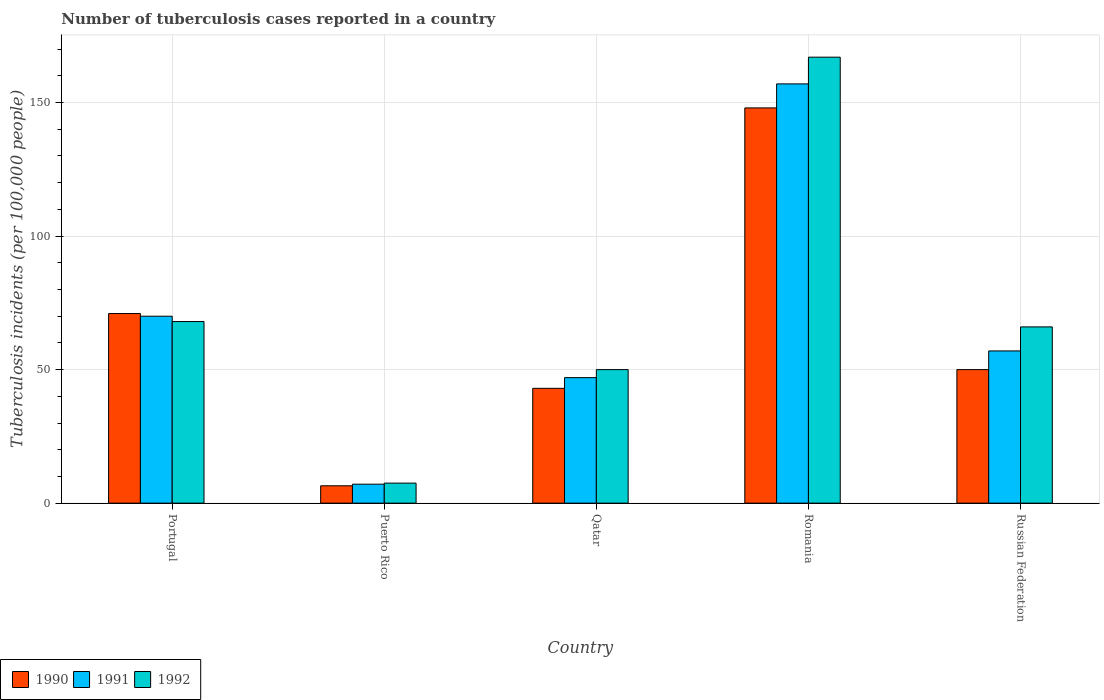How many groups of bars are there?
Your answer should be very brief. 5. Are the number of bars per tick equal to the number of legend labels?
Provide a short and direct response. Yes. How many bars are there on the 3rd tick from the right?
Keep it short and to the point. 3. What is the label of the 3rd group of bars from the left?
Provide a succinct answer. Qatar. What is the number of tuberculosis cases reported in in 1990 in Russian Federation?
Give a very brief answer. 50. Across all countries, what is the maximum number of tuberculosis cases reported in in 1992?
Your response must be concise. 167. Across all countries, what is the minimum number of tuberculosis cases reported in in 1991?
Make the answer very short. 7.1. In which country was the number of tuberculosis cases reported in in 1992 maximum?
Keep it short and to the point. Romania. In which country was the number of tuberculosis cases reported in in 1992 minimum?
Your answer should be compact. Puerto Rico. What is the total number of tuberculosis cases reported in in 1991 in the graph?
Give a very brief answer. 338.1. What is the difference between the number of tuberculosis cases reported in in 1992 in Portugal and that in Puerto Rico?
Your response must be concise. 60.5. What is the average number of tuberculosis cases reported in in 1991 per country?
Provide a short and direct response. 67.62. In how many countries, is the number of tuberculosis cases reported in in 1991 greater than 50?
Your response must be concise. 3. What is the ratio of the number of tuberculosis cases reported in in 1991 in Portugal to that in Puerto Rico?
Provide a short and direct response. 9.86. What is the difference between the highest and the second highest number of tuberculosis cases reported in in 1990?
Provide a short and direct response. -98. What is the difference between the highest and the lowest number of tuberculosis cases reported in in 1992?
Your response must be concise. 159.5. What does the 3rd bar from the left in Puerto Rico represents?
Keep it short and to the point. 1992. How many bars are there?
Provide a succinct answer. 15. Are all the bars in the graph horizontal?
Your response must be concise. No. Are the values on the major ticks of Y-axis written in scientific E-notation?
Offer a terse response. No. Does the graph contain grids?
Your answer should be very brief. Yes. How many legend labels are there?
Your answer should be very brief. 3. What is the title of the graph?
Provide a succinct answer. Number of tuberculosis cases reported in a country. What is the label or title of the Y-axis?
Your answer should be very brief. Tuberculosis incidents (per 100,0 people). What is the Tuberculosis incidents (per 100,000 people) of 1992 in Portugal?
Keep it short and to the point. 68. What is the Tuberculosis incidents (per 100,000 people) of 1990 in Puerto Rico?
Your response must be concise. 6.5. What is the Tuberculosis incidents (per 100,000 people) of 1992 in Puerto Rico?
Keep it short and to the point. 7.5. What is the Tuberculosis incidents (per 100,000 people) of 1990 in Qatar?
Offer a very short reply. 43. What is the Tuberculosis incidents (per 100,000 people) of 1990 in Romania?
Offer a very short reply. 148. What is the Tuberculosis incidents (per 100,000 people) of 1991 in Romania?
Ensure brevity in your answer.  157. What is the Tuberculosis incidents (per 100,000 people) of 1992 in Romania?
Your answer should be very brief. 167. Across all countries, what is the maximum Tuberculosis incidents (per 100,000 people) in 1990?
Offer a very short reply. 148. Across all countries, what is the maximum Tuberculosis incidents (per 100,000 people) in 1991?
Give a very brief answer. 157. Across all countries, what is the maximum Tuberculosis incidents (per 100,000 people) in 1992?
Make the answer very short. 167. Across all countries, what is the minimum Tuberculosis incidents (per 100,000 people) of 1990?
Provide a short and direct response. 6.5. Across all countries, what is the minimum Tuberculosis incidents (per 100,000 people) in 1992?
Your answer should be compact. 7.5. What is the total Tuberculosis incidents (per 100,000 people) of 1990 in the graph?
Your answer should be compact. 318.5. What is the total Tuberculosis incidents (per 100,000 people) of 1991 in the graph?
Offer a very short reply. 338.1. What is the total Tuberculosis incidents (per 100,000 people) in 1992 in the graph?
Make the answer very short. 358.5. What is the difference between the Tuberculosis incidents (per 100,000 people) in 1990 in Portugal and that in Puerto Rico?
Your answer should be very brief. 64.5. What is the difference between the Tuberculosis incidents (per 100,000 people) of 1991 in Portugal and that in Puerto Rico?
Your response must be concise. 62.9. What is the difference between the Tuberculosis incidents (per 100,000 people) of 1992 in Portugal and that in Puerto Rico?
Your response must be concise. 60.5. What is the difference between the Tuberculosis incidents (per 100,000 people) in 1990 in Portugal and that in Qatar?
Offer a terse response. 28. What is the difference between the Tuberculosis incidents (per 100,000 people) of 1991 in Portugal and that in Qatar?
Your response must be concise. 23. What is the difference between the Tuberculosis incidents (per 100,000 people) in 1992 in Portugal and that in Qatar?
Offer a very short reply. 18. What is the difference between the Tuberculosis incidents (per 100,000 people) of 1990 in Portugal and that in Romania?
Provide a succinct answer. -77. What is the difference between the Tuberculosis incidents (per 100,000 people) of 1991 in Portugal and that in Romania?
Ensure brevity in your answer.  -87. What is the difference between the Tuberculosis incidents (per 100,000 people) in 1992 in Portugal and that in Romania?
Give a very brief answer. -99. What is the difference between the Tuberculosis incidents (per 100,000 people) of 1991 in Portugal and that in Russian Federation?
Keep it short and to the point. 13. What is the difference between the Tuberculosis incidents (per 100,000 people) of 1992 in Portugal and that in Russian Federation?
Keep it short and to the point. 2. What is the difference between the Tuberculosis incidents (per 100,000 people) of 1990 in Puerto Rico and that in Qatar?
Keep it short and to the point. -36.5. What is the difference between the Tuberculosis incidents (per 100,000 people) of 1991 in Puerto Rico and that in Qatar?
Keep it short and to the point. -39.9. What is the difference between the Tuberculosis incidents (per 100,000 people) of 1992 in Puerto Rico and that in Qatar?
Your answer should be compact. -42.5. What is the difference between the Tuberculosis incidents (per 100,000 people) in 1990 in Puerto Rico and that in Romania?
Provide a short and direct response. -141.5. What is the difference between the Tuberculosis incidents (per 100,000 people) in 1991 in Puerto Rico and that in Romania?
Ensure brevity in your answer.  -149.9. What is the difference between the Tuberculosis incidents (per 100,000 people) of 1992 in Puerto Rico and that in Romania?
Your answer should be compact. -159.5. What is the difference between the Tuberculosis incidents (per 100,000 people) of 1990 in Puerto Rico and that in Russian Federation?
Your answer should be very brief. -43.5. What is the difference between the Tuberculosis incidents (per 100,000 people) in 1991 in Puerto Rico and that in Russian Federation?
Offer a terse response. -49.9. What is the difference between the Tuberculosis incidents (per 100,000 people) of 1992 in Puerto Rico and that in Russian Federation?
Offer a terse response. -58.5. What is the difference between the Tuberculosis incidents (per 100,000 people) in 1990 in Qatar and that in Romania?
Keep it short and to the point. -105. What is the difference between the Tuberculosis incidents (per 100,000 people) of 1991 in Qatar and that in Romania?
Ensure brevity in your answer.  -110. What is the difference between the Tuberculosis incidents (per 100,000 people) of 1992 in Qatar and that in Romania?
Offer a terse response. -117. What is the difference between the Tuberculosis incidents (per 100,000 people) of 1990 in Qatar and that in Russian Federation?
Your answer should be very brief. -7. What is the difference between the Tuberculosis incidents (per 100,000 people) of 1991 in Qatar and that in Russian Federation?
Provide a succinct answer. -10. What is the difference between the Tuberculosis incidents (per 100,000 people) in 1992 in Qatar and that in Russian Federation?
Ensure brevity in your answer.  -16. What is the difference between the Tuberculosis incidents (per 100,000 people) in 1991 in Romania and that in Russian Federation?
Your answer should be very brief. 100. What is the difference between the Tuberculosis incidents (per 100,000 people) in 1992 in Romania and that in Russian Federation?
Make the answer very short. 101. What is the difference between the Tuberculosis incidents (per 100,000 people) in 1990 in Portugal and the Tuberculosis incidents (per 100,000 people) in 1991 in Puerto Rico?
Ensure brevity in your answer.  63.9. What is the difference between the Tuberculosis incidents (per 100,000 people) in 1990 in Portugal and the Tuberculosis incidents (per 100,000 people) in 1992 in Puerto Rico?
Keep it short and to the point. 63.5. What is the difference between the Tuberculosis incidents (per 100,000 people) of 1991 in Portugal and the Tuberculosis incidents (per 100,000 people) of 1992 in Puerto Rico?
Your answer should be compact. 62.5. What is the difference between the Tuberculosis incidents (per 100,000 people) in 1990 in Portugal and the Tuberculosis incidents (per 100,000 people) in 1991 in Qatar?
Keep it short and to the point. 24. What is the difference between the Tuberculosis incidents (per 100,000 people) of 1990 in Portugal and the Tuberculosis incidents (per 100,000 people) of 1992 in Qatar?
Offer a terse response. 21. What is the difference between the Tuberculosis incidents (per 100,000 people) of 1991 in Portugal and the Tuberculosis incidents (per 100,000 people) of 1992 in Qatar?
Offer a very short reply. 20. What is the difference between the Tuberculosis incidents (per 100,000 people) of 1990 in Portugal and the Tuberculosis incidents (per 100,000 people) of 1991 in Romania?
Offer a terse response. -86. What is the difference between the Tuberculosis incidents (per 100,000 people) in 1990 in Portugal and the Tuberculosis incidents (per 100,000 people) in 1992 in Romania?
Provide a short and direct response. -96. What is the difference between the Tuberculosis incidents (per 100,000 people) of 1991 in Portugal and the Tuberculosis incidents (per 100,000 people) of 1992 in Romania?
Offer a very short reply. -97. What is the difference between the Tuberculosis incidents (per 100,000 people) of 1990 in Portugal and the Tuberculosis incidents (per 100,000 people) of 1991 in Russian Federation?
Ensure brevity in your answer.  14. What is the difference between the Tuberculosis incidents (per 100,000 people) of 1990 in Portugal and the Tuberculosis incidents (per 100,000 people) of 1992 in Russian Federation?
Your response must be concise. 5. What is the difference between the Tuberculosis incidents (per 100,000 people) in 1990 in Puerto Rico and the Tuberculosis incidents (per 100,000 people) in 1991 in Qatar?
Offer a terse response. -40.5. What is the difference between the Tuberculosis incidents (per 100,000 people) of 1990 in Puerto Rico and the Tuberculosis incidents (per 100,000 people) of 1992 in Qatar?
Give a very brief answer. -43.5. What is the difference between the Tuberculosis incidents (per 100,000 people) of 1991 in Puerto Rico and the Tuberculosis incidents (per 100,000 people) of 1992 in Qatar?
Your answer should be compact. -42.9. What is the difference between the Tuberculosis incidents (per 100,000 people) in 1990 in Puerto Rico and the Tuberculosis incidents (per 100,000 people) in 1991 in Romania?
Provide a succinct answer. -150.5. What is the difference between the Tuberculosis incidents (per 100,000 people) of 1990 in Puerto Rico and the Tuberculosis incidents (per 100,000 people) of 1992 in Romania?
Your answer should be compact. -160.5. What is the difference between the Tuberculosis incidents (per 100,000 people) of 1991 in Puerto Rico and the Tuberculosis incidents (per 100,000 people) of 1992 in Romania?
Offer a very short reply. -159.9. What is the difference between the Tuberculosis incidents (per 100,000 people) in 1990 in Puerto Rico and the Tuberculosis incidents (per 100,000 people) in 1991 in Russian Federation?
Ensure brevity in your answer.  -50.5. What is the difference between the Tuberculosis incidents (per 100,000 people) in 1990 in Puerto Rico and the Tuberculosis incidents (per 100,000 people) in 1992 in Russian Federation?
Keep it short and to the point. -59.5. What is the difference between the Tuberculosis incidents (per 100,000 people) in 1991 in Puerto Rico and the Tuberculosis incidents (per 100,000 people) in 1992 in Russian Federation?
Ensure brevity in your answer.  -58.9. What is the difference between the Tuberculosis incidents (per 100,000 people) in 1990 in Qatar and the Tuberculosis incidents (per 100,000 people) in 1991 in Romania?
Offer a very short reply. -114. What is the difference between the Tuberculosis incidents (per 100,000 people) of 1990 in Qatar and the Tuberculosis incidents (per 100,000 people) of 1992 in Romania?
Offer a terse response. -124. What is the difference between the Tuberculosis incidents (per 100,000 people) of 1991 in Qatar and the Tuberculosis incidents (per 100,000 people) of 1992 in Romania?
Your answer should be compact. -120. What is the difference between the Tuberculosis incidents (per 100,000 people) in 1990 in Romania and the Tuberculosis incidents (per 100,000 people) in 1991 in Russian Federation?
Ensure brevity in your answer.  91. What is the difference between the Tuberculosis incidents (per 100,000 people) in 1991 in Romania and the Tuberculosis incidents (per 100,000 people) in 1992 in Russian Federation?
Ensure brevity in your answer.  91. What is the average Tuberculosis incidents (per 100,000 people) of 1990 per country?
Provide a short and direct response. 63.7. What is the average Tuberculosis incidents (per 100,000 people) in 1991 per country?
Offer a terse response. 67.62. What is the average Tuberculosis incidents (per 100,000 people) of 1992 per country?
Offer a terse response. 71.7. What is the difference between the Tuberculosis incidents (per 100,000 people) of 1990 and Tuberculosis incidents (per 100,000 people) of 1991 in Portugal?
Give a very brief answer. 1. What is the difference between the Tuberculosis incidents (per 100,000 people) in 1991 and Tuberculosis incidents (per 100,000 people) in 1992 in Portugal?
Provide a succinct answer. 2. What is the difference between the Tuberculosis incidents (per 100,000 people) in 1990 and Tuberculosis incidents (per 100,000 people) in 1991 in Puerto Rico?
Offer a terse response. -0.6. What is the difference between the Tuberculosis incidents (per 100,000 people) of 1991 and Tuberculosis incidents (per 100,000 people) of 1992 in Puerto Rico?
Your answer should be very brief. -0.4. What is the difference between the Tuberculosis incidents (per 100,000 people) in 1990 and Tuberculosis incidents (per 100,000 people) in 1991 in Qatar?
Your response must be concise. -4. What is the difference between the Tuberculosis incidents (per 100,000 people) of 1991 and Tuberculosis incidents (per 100,000 people) of 1992 in Qatar?
Offer a very short reply. -3. What is the difference between the Tuberculosis incidents (per 100,000 people) in 1991 and Tuberculosis incidents (per 100,000 people) in 1992 in Romania?
Your response must be concise. -10. What is the difference between the Tuberculosis incidents (per 100,000 people) in 1990 and Tuberculosis incidents (per 100,000 people) in 1992 in Russian Federation?
Provide a short and direct response. -16. What is the difference between the Tuberculosis incidents (per 100,000 people) of 1991 and Tuberculosis incidents (per 100,000 people) of 1992 in Russian Federation?
Keep it short and to the point. -9. What is the ratio of the Tuberculosis incidents (per 100,000 people) of 1990 in Portugal to that in Puerto Rico?
Make the answer very short. 10.92. What is the ratio of the Tuberculosis incidents (per 100,000 people) in 1991 in Portugal to that in Puerto Rico?
Provide a short and direct response. 9.86. What is the ratio of the Tuberculosis incidents (per 100,000 people) in 1992 in Portugal to that in Puerto Rico?
Your answer should be very brief. 9.07. What is the ratio of the Tuberculosis incidents (per 100,000 people) in 1990 in Portugal to that in Qatar?
Keep it short and to the point. 1.65. What is the ratio of the Tuberculosis incidents (per 100,000 people) of 1991 in Portugal to that in Qatar?
Make the answer very short. 1.49. What is the ratio of the Tuberculosis incidents (per 100,000 people) of 1992 in Portugal to that in Qatar?
Offer a very short reply. 1.36. What is the ratio of the Tuberculosis incidents (per 100,000 people) of 1990 in Portugal to that in Romania?
Offer a very short reply. 0.48. What is the ratio of the Tuberculosis incidents (per 100,000 people) of 1991 in Portugal to that in Romania?
Give a very brief answer. 0.45. What is the ratio of the Tuberculosis incidents (per 100,000 people) of 1992 in Portugal to that in Romania?
Your response must be concise. 0.41. What is the ratio of the Tuberculosis incidents (per 100,000 people) of 1990 in Portugal to that in Russian Federation?
Provide a succinct answer. 1.42. What is the ratio of the Tuberculosis incidents (per 100,000 people) of 1991 in Portugal to that in Russian Federation?
Your answer should be very brief. 1.23. What is the ratio of the Tuberculosis incidents (per 100,000 people) of 1992 in Portugal to that in Russian Federation?
Provide a short and direct response. 1.03. What is the ratio of the Tuberculosis incidents (per 100,000 people) in 1990 in Puerto Rico to that in Qatar?
Give a very brief answer. 0.15. What is the ratio of the Tuberculosis incidents (per 100,000 people) of 1991 in Puerto Rico to that in Qatar?
Ensure brevity in your answer.  0.15. What is the ratio of the Tuberculosis incidents (per 100,000 people) in 1992 in Puerto Rico to that in Qatar?
Offer a terse response. 0.15. What is the ratio of the Tuberculosis incidents (per 100,000 people) in 1990 in Puerto Rico to that in Romania?
Your answer should be very brief. 0.04. What is the ratio of the Tuberculosis incidents (per 100,000 people) of 1991 in Puerto Rico to that in Romania?
Offer a very short reply. 0.05. What is the ratio of the Tuberculosis incidents (per 100,000 people) in 1992 in Puerto Rico to that in Romania?
Your answer should be compact. 0.04. What is the ratio of the Tuberculosis incidents (per 100,000 people) of 1990 in Puerto Rico to that in Russian Federation?
Your response must be concise. 0.13. What is the ratio of the Tuberculosis incidents (per 100,000 people) of 1991 in Puerto Rico to that in Russian Federation?
Your answer should be very brief. 0.12. What is the ratio of the Tuberculosis incidents (per 100,000 people) of 1992 in Puerto Rico to that in Russian Federation?
Your answer should be compact. 0.11. What is the ratio of the Tuberculosis incidents (per 100,000 people) of 1990 in Qatar to that in Romania?
Your response must be concise. 0.29. What is the ratio of the Tuberculosis incidents (per 100,000 people) of 1991 in Qatar to that in Romania?
Your answer should be compact. 0.3. What is the ratio of the Tuberculosis incidents (per 100,000 people) of 1992 in Qatar to that in Romania?
Ensure brevity in your answer.  0.3. What is the ratio of the Tuberculosis incidents (per 100,000 people) in 1990 in Qatar to that in Russian Federation?
Your answer should be compact. 0.86. What is the ratio of the Tuberculosis incidents (per 100,000 people) in 1991 in Qatar to that in Russian Federation?
Offer a very short reply. 0.82. What is the ratio of the Tuberculosis incidents (per 100,000 people) in 1992 in Qatar to that in Russian Federation?
Make the answer very short. 0.76. What is the ratio of the Tuberculosis incidents (per 100,000 people) of 1990 in Romania to that in Russian Federation?
Your answer should be very brief. 2.96. What is the ratio of the Tuberculosis incidents (per 100,000 people) of 1991 in Romania to that in Russian Federation?
Ensure brevity in your answer.  2.75. What is the ratio of the Tuberculosis incidents (per 100,000 people) of 1992 in Romania to that in Russian Federation?
Provide a succinct answer. 2.53. What is the difference between the highest and the second highest Tuberculosis incidents (per 100,000 people) in 1991?
Your response must be concise. 87. What is the difference between the highest and the lowest Tuberculosis incidents (per 100,000 people) of 1990?
Your answer should be very brief. 141.5. What is the difference between the highest and the lowest Tuberculosis incidents (per 100,000 people) in 1991?
Provide a short and direct response. 149.9. What is the difference between the highest and the lowest Tuberculosis incidents (per 100,000 people) of 1992?
Provide a short and direct response. 159.5. 